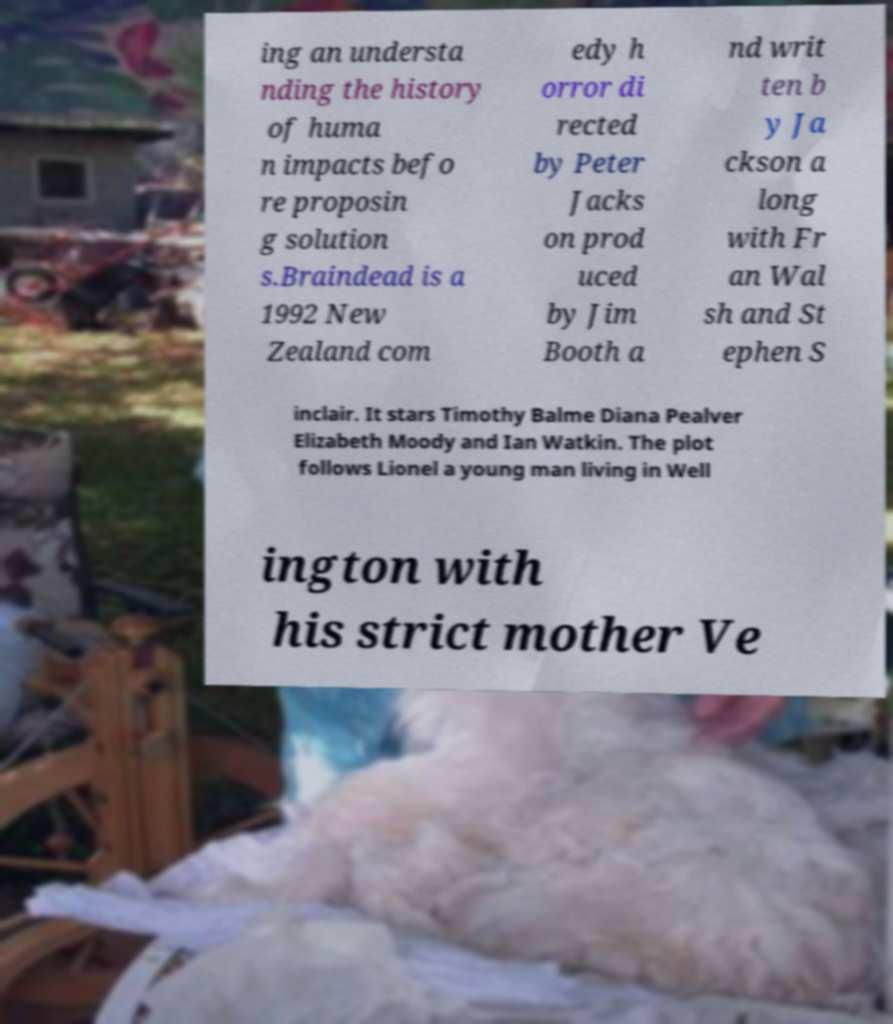Could you assist in decoding the text presented in this image and type it out clearly? ing an understa nding the history of huma n impacts befo re proposin g solution s.Braindead is a 1992 New Zealand com edy h orror di rected by Peter Jacks on prod uced by Jim Booth a nd writ ten b y Ja ckson a long with Fr an Wal sh and St ephen S inclair. It stars Timothy Balme Diana Pealver Elizabeth Moody and Ian Watkin. The plot follows Lionel a young man living in Well ington with his strict mother Ve 